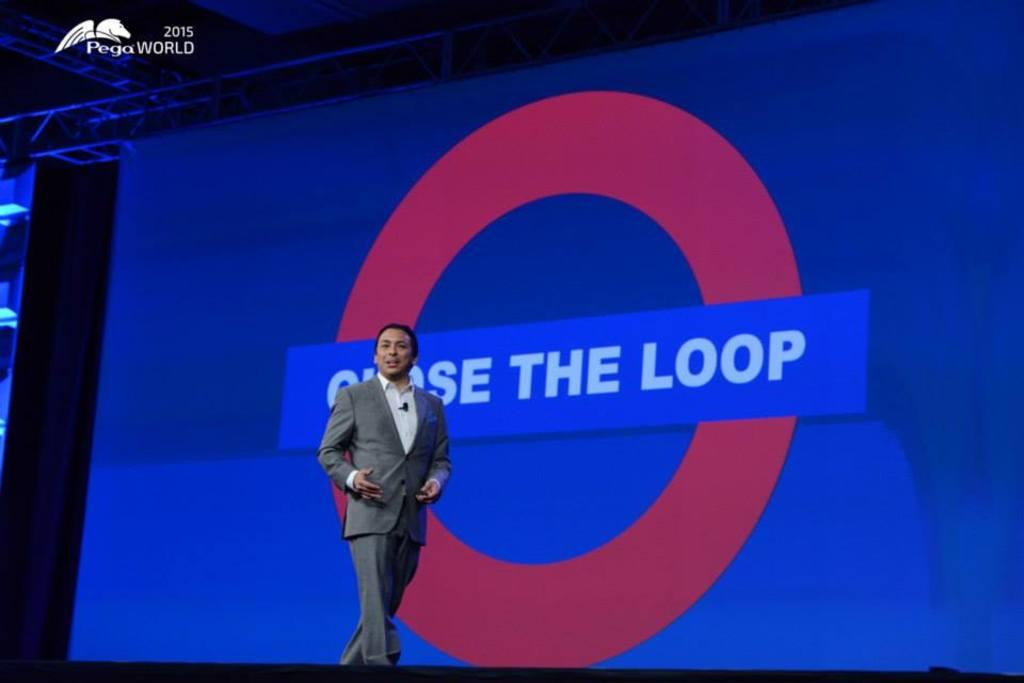What is the main subject of the image? There is a person standing in the image. What else can be seen in the image besides the person? There is a screen in the image. Is there any additional information or markings on the image? Yes, there is a watermark on the image. What type of seed is being planted by the team in the image? There is no team or seed present in the image; it only features a person standing and a screen. 